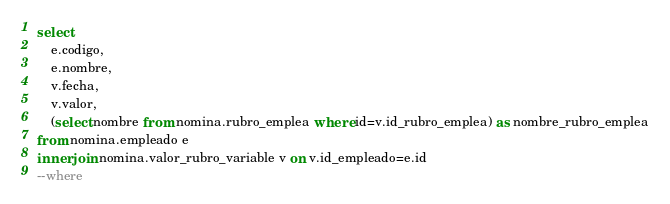<code> <loc_0><loc_0><loc_500><loc_500><_SQL_>select 
	e.codigo,
	e.nombre,
	v.fecha,
	v.valor,
	(select nombre from nomina.rubro_emplea where id=v.id_rubro_emplea) as nombre_rubro_emplea
from nomina.empleado e
inner join nomina.valor_rubro_variable v on v.id_empleado=e.id
--where</code> 